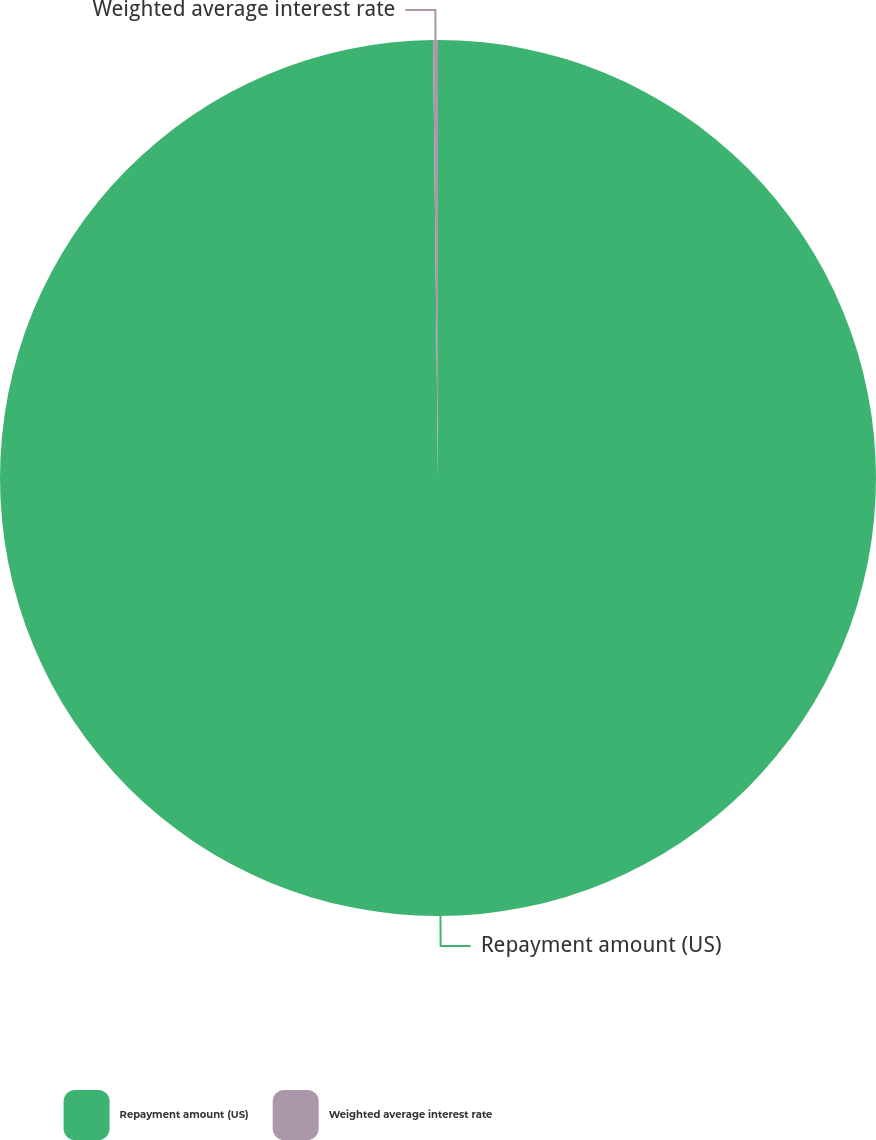Convert chart to OTSL. <chart><loc_0><loc_0><loc_500><loc_500><pie_chart><fcel>Repayment amount (US)<fcel>Weighted average interest rate<nl><fcel>99.82%<fcel>0.18%<nl></chart> 